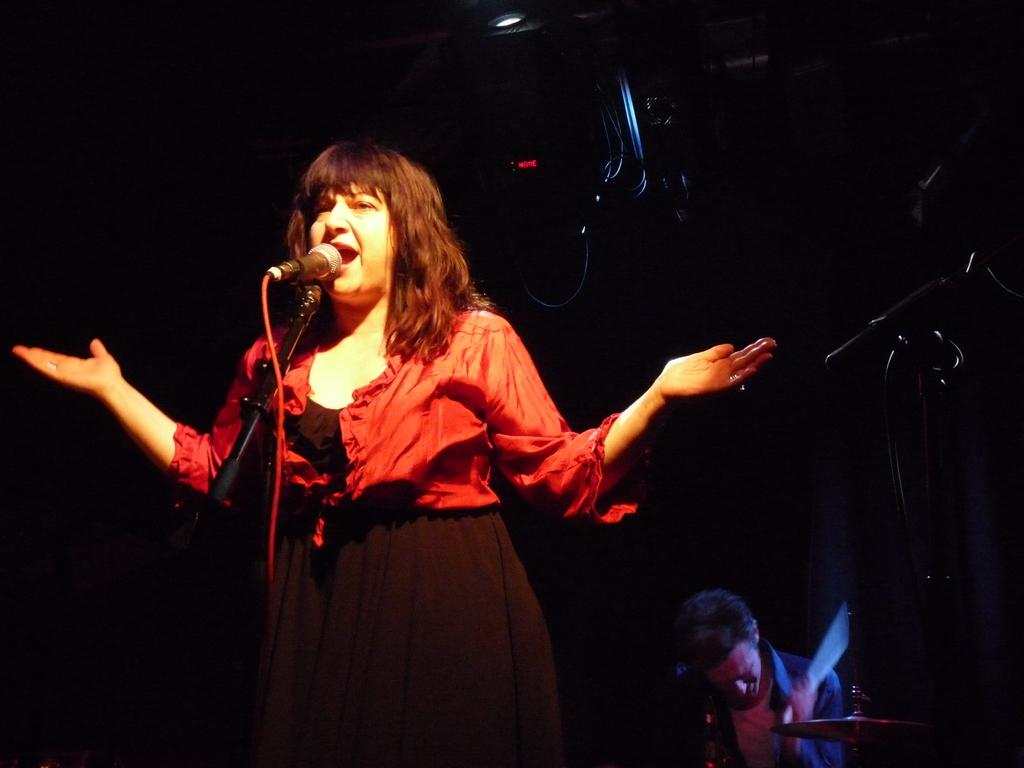Who is the main subject in the image? There is a woman in the image. What is the woman doing in the image? The woman is standing and singing on a mic. Are there any other people in the image? Yes, there is a man in the image. What can be seen in the background of the image? The background of the image is dark. What additional elements are present in the image? There are lights visible in the image. Can you see the sun shining in the image? No, the sun is not visible in the image. Is there a cat present in the image? No, there is no cat present in the image. 